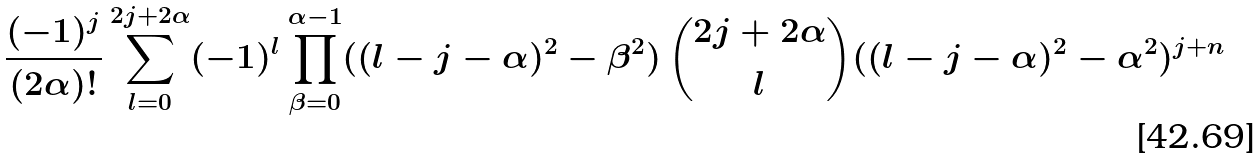<formula> <loc_0><loc_0><loc_500><loc_500>\frac { ( - 1 ) ^ { j } } { ( 2 \alpha ) ! } \sum _ { l = 0 } ^ { 2 j + 2 \alpha } ( - 1 ) ^ { l } \prod _ { \beta = 0 } ^ { \alpha - 1 } ( ( l - j - \alpha ) ^ { 2 } - \beta ^ { 2 } ) \, \binom { 2 j + 2 \alpha } { l } ( ( l - j - \alpha ) ^ { 2 } - \alpha ^ { 2 } ) ^ { j + n }</formula> 